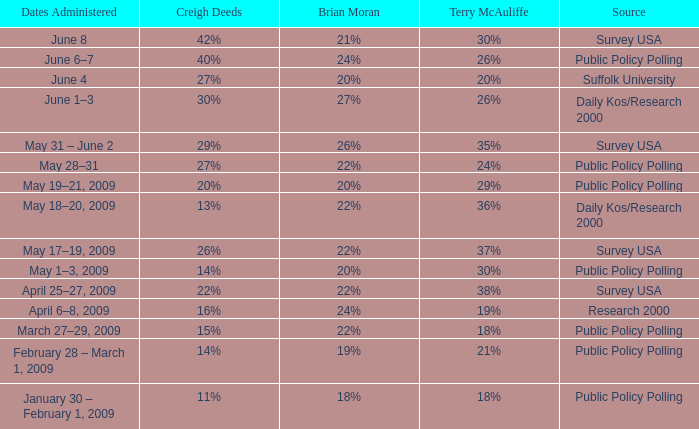Which Source has Terry McAuliffe of 36% Daily Kos/Research 2000. 